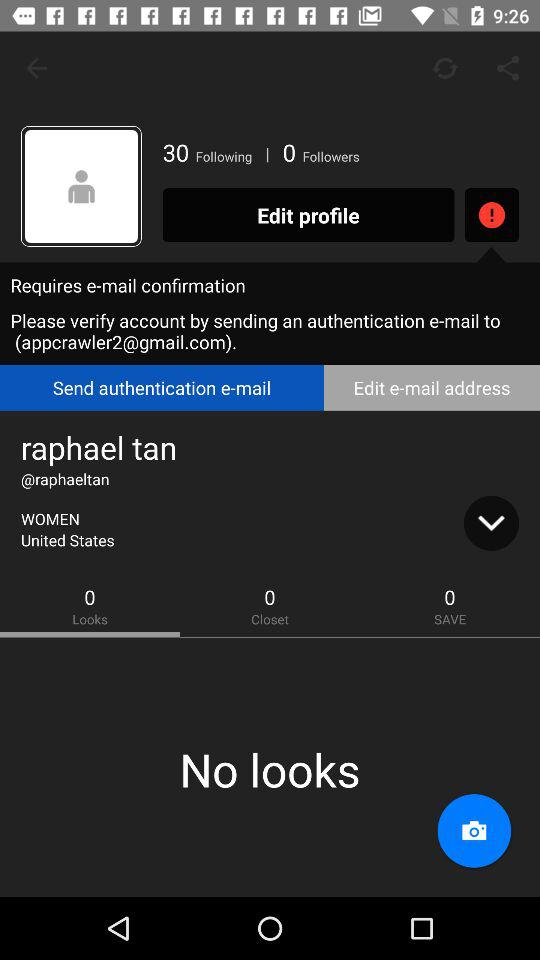How many followers does the user have?
Answer the question using a single word or phrase. 0 